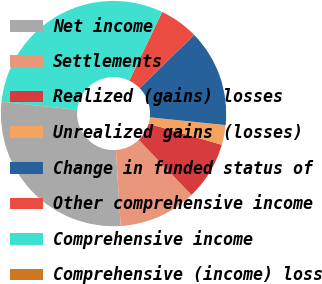Convert chart. <chart><loc_0><loc_0><loc_500><loc_500><pie_chart><fcel>Net income<fcel>Settlements<fcel>Realized (gains) losses<fcel>Unrealized gains (losses)<fcel>Change in funded status of<fcel>Other comprehensive income<fcel>Comprehensive income<fcel>Comprehensive (income) loss<nl><fcel>27.64%<fcel>11.15%<fcel>8.38%<fcel>2.83%<fcel>13.93%<fcel>5.6%<fcel>30.42%<fcel>0.05%<nl></chart> 